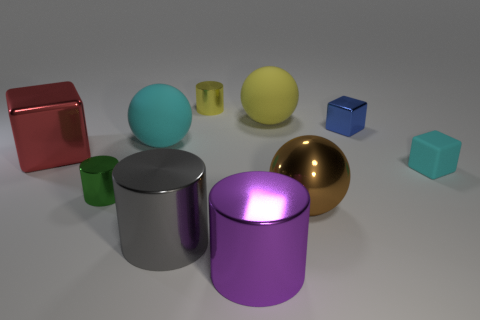What color is the other big object that is the same shape as the big purple object?
Offer a terse response. Gray. Do the shiny cube that is to the right of the brown metal ball and the tiny rubber thing have the same size?
Your response must be concise. Yes. Are there fewer yellow balls that are left of the cyan sphere than brown things?
Offer a very short reply. Yes. Is there any other thing that is the same size as the yellow shiny cylinder?
Offer a terse response. Yes. There is a gray shiny cylinder in front of the small cylinder that is behind the big cyan matte ball; how big is it?
Keep it short and to the point. Large. Is there any other thing that is the same shape as the brown object?
Offer a terse response. Yes. Is the number of metal spheres less than the number of green matte things?
Your response must be concise. No. There is a cylinder that is both in front of the big red metal block and behind the large gray object; what is its material?
Make the answer very short. Metal. Are there any small cyan blocks that are in front of the cyan rubber thing right of the cyan ball?
Offer a very short reply. No. How many objects are either big balls or tiny metallic objects?
Keep it short and to the point. 6. 